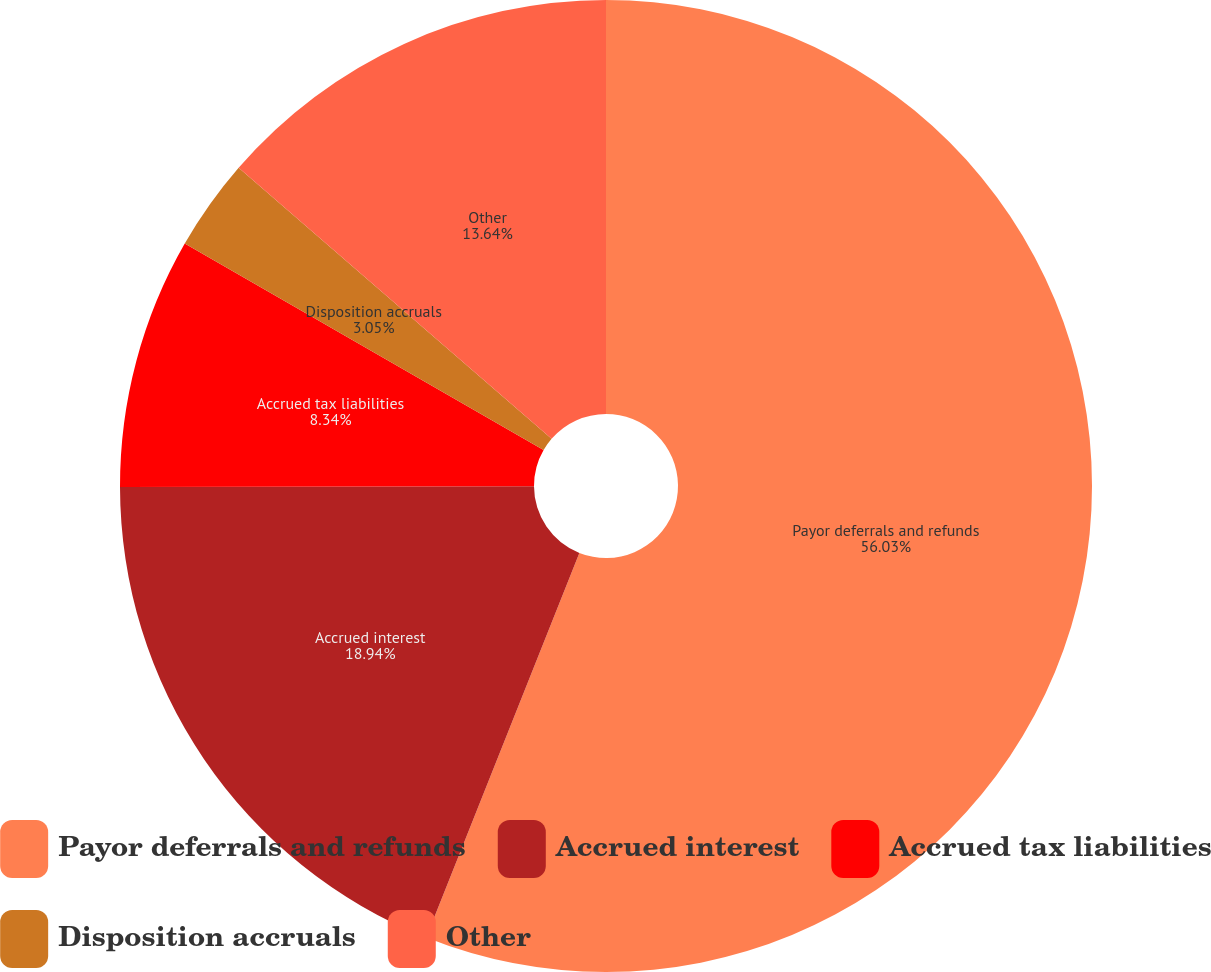Convert chart to OTSL. <chart><loc_0><loc_0><loc_500><loc_500><pie_chart><fcel>Payor deferrals and refunds<fcel>Accrued interest<fcel>Accrued tax liabilities<fcel>Disposition accruals<fcel>Other<nl><fcel>56.03%<fcel>18.94%<fcel>8.34%<fcel>3.05%<fcel>13.64%<nl></chart> 